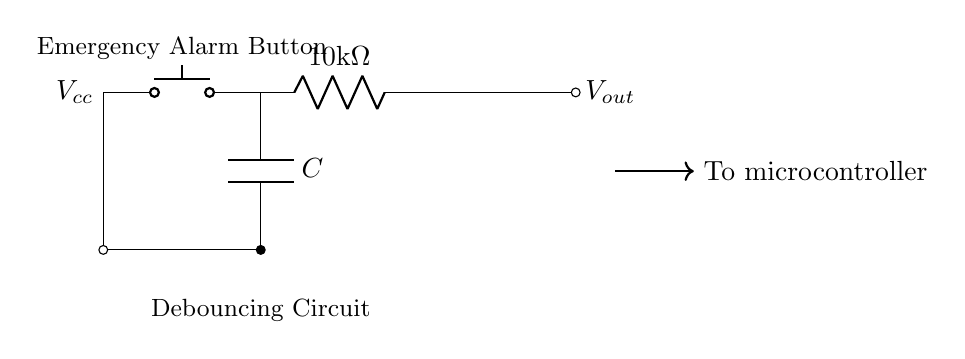What type of button is used in this circuit? The circuit diagram shows a push button component, which is indicated by the symbol for a push button switch in the diagram.
Answer: Push button What is the resistance value in the circuit? The resistor symbol in the diagram is labeled with a value of 10 kilo-ohms, which indicates the resistance in the circuit.
Answer: 10 kilo-ohms What does the capacitor do in this circuit? The capacitor is used as a debouncing element to filter out noise from the rapid mechanical action of the push button, allowing for stable voltage output.
Answer: Debouncing What is the output voltage connected to? The output of the circuit is connected to a microcontroller, which is shown in the diagram with an arrow pointing to it.
Answer: Microcontroller What is the total voltage supplied to the circuit? The voltage labeled at the highest point of the circuit, denoted as Vcc, indicates the total supply voltage for the circuit.
Answer: Vcc Which component is responsible for filtering in the circuit? The capacitor is responsible for filtering, as it charges and discharges to smooth out the voltage signal triggered by the push button input.
Answer: Capacitor How does the resistor and capacitor network behave when the button is pressed? When the button is pressed, the resistor limits the current and the capacitor charges, affecting the timing of the voltage rise at the output, helping to reduce bounces.
Answer: RC timing 